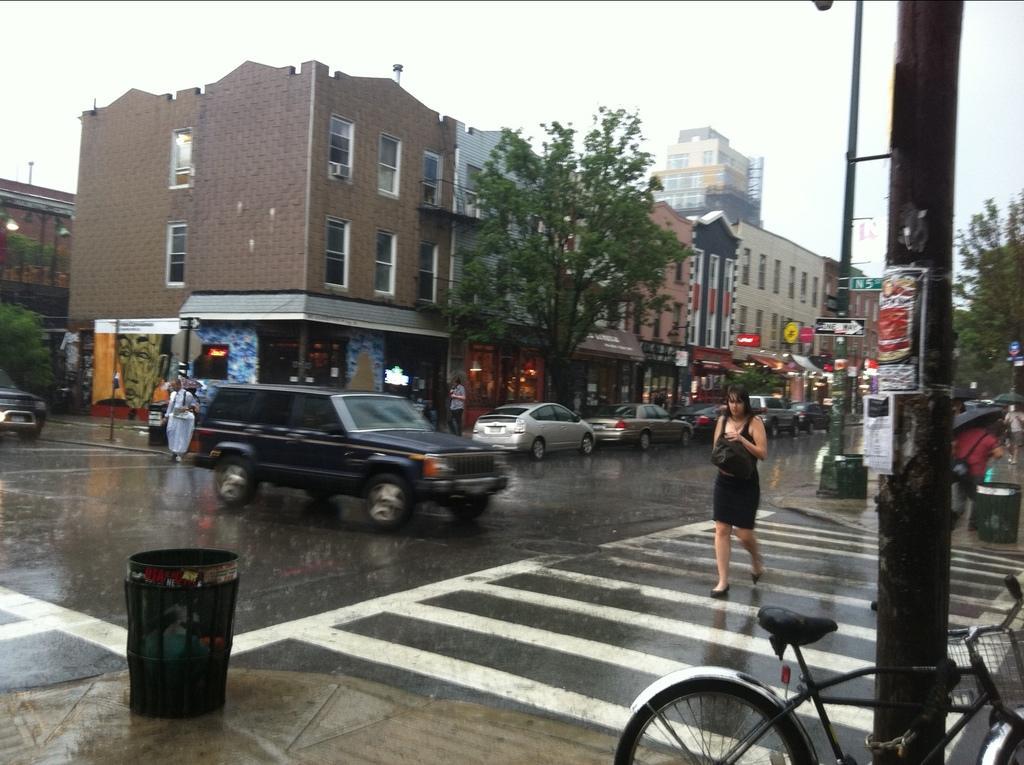Can you describe this image briefly? This image is clicked on the road. There is a woman walking on the zebra crossing. There are vehicles moving on the road. Beside the road there are walkways. There are dustbins, poles, sign board poles, cycles and a few people walking on the walkway. In the background there are buildings. There are boards with text on the walls of the building. In front of the buildings there are trees. At the top there is the sky. It is raining in the image. 